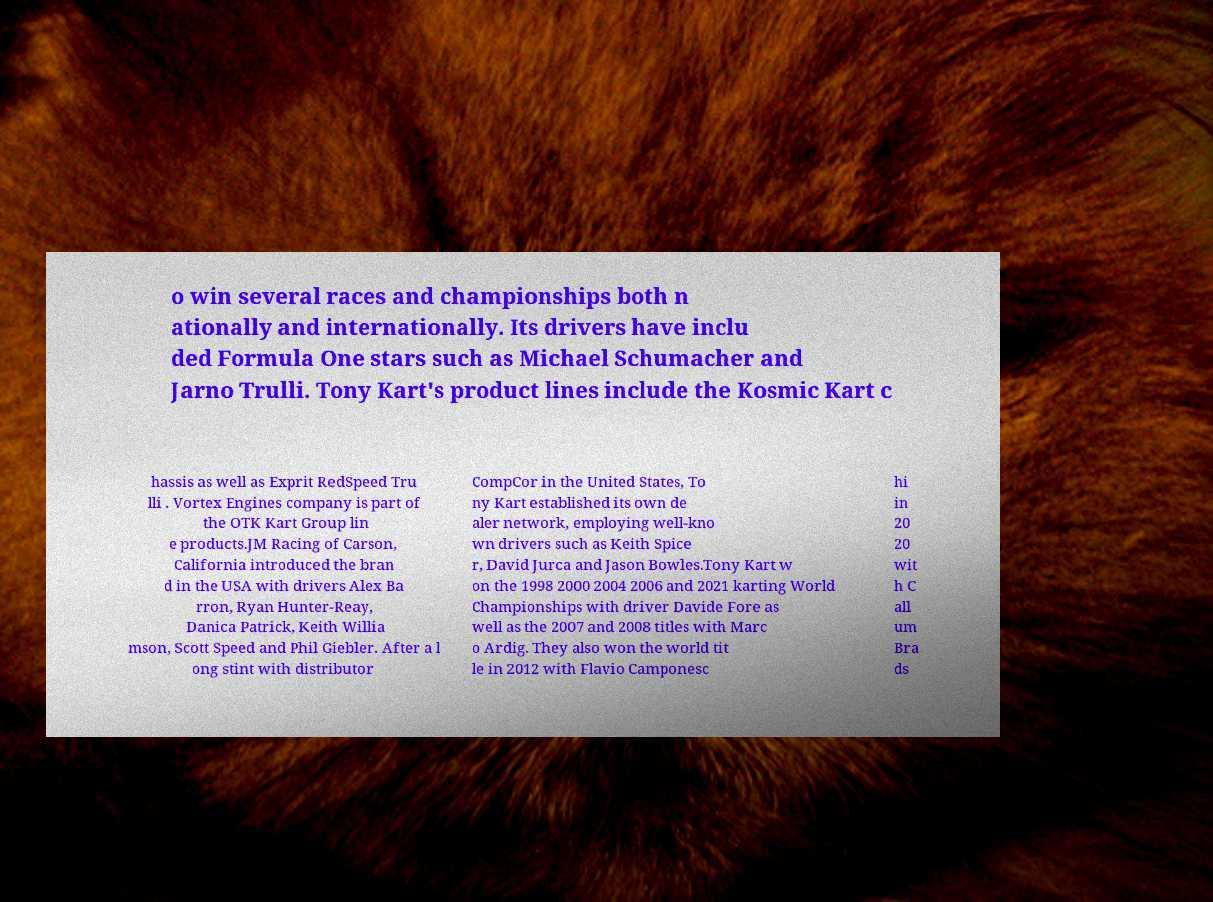Could you extract and type out the text from this image? o win several races and championships both n ationally and internationally. Its drivers have inclu ded Formula One stars such as Michael Schumacher and Jarno Trulli. Tony Kart's product lines include the Kosmic Kart c hassis as well as Exprit RedSpeed Tru lli . Vortex Engines company is part of the OTK Kart Group lin e products.JM Racing of Carson, California introduced the bran d in the USA with drivers Alex Ba rron, Ryan Hunter-Reay, Danica Patrick, Keith Willia mson, Scott Speed and Phil Giebler. After a l ong stint with distributor CompCor in the United States, To ny Kart established its own de aler network, employing well-kno wn drivers such as Keith Spice r, David Jurca and Jason Bowles.Tony Kart w on the 1998 2000 2004 2006 and 2021 karting World Championships with driver Davide Fore as well as the 2007 and 2008 titles with Marc o Ardig. They also won the world tit le in 2012 with Flavio Camponesc hi in 20 20 wit h C all um Bra ds 